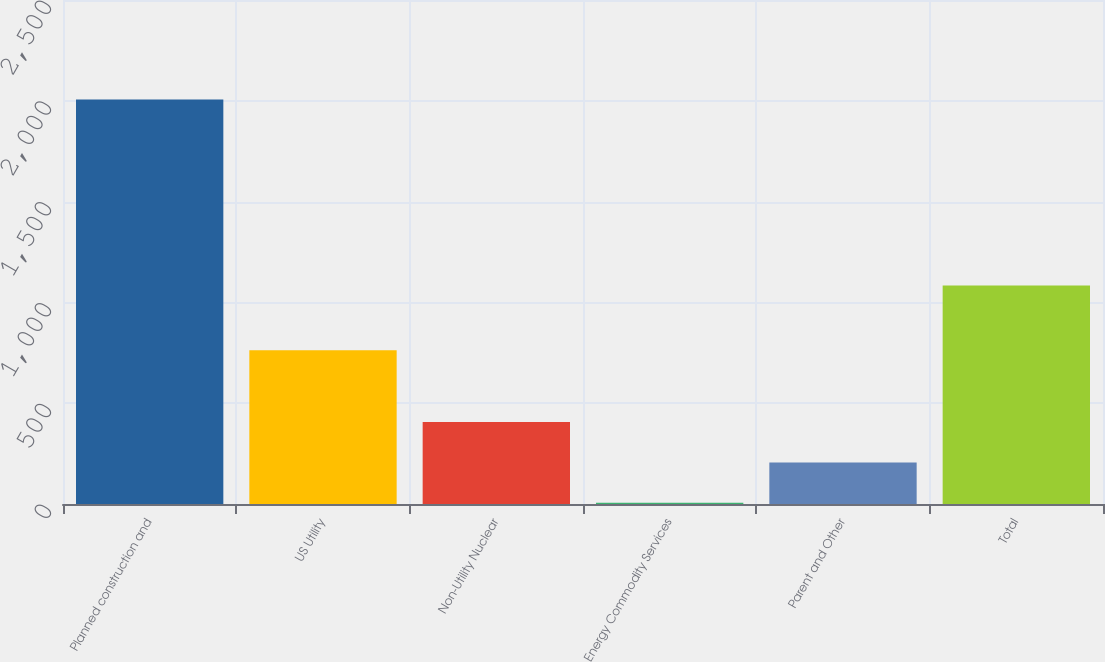Convert chart to OTSL. <chart><loc_0><loc_0><loc_500><loc_500><bar_chart><fcel>Planned construction and<fcel>US Utility<fcel>Non-Utility Nuclear<fcel>Energy Commodity Services<fcel>Parent and Other<fcel>Total<nl><fcel>2007<fcel>763<fcel>406.2<fcel>6<fcel>206.1<fcel>1084<nl></chart> 